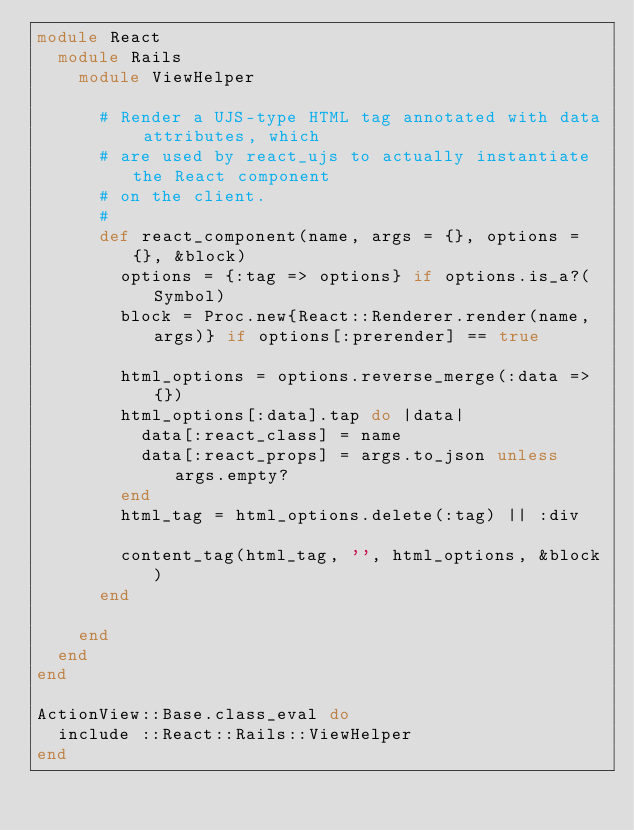<code> <loc_0><loc_0><loc_500><loc_500><_Ruby_>module React
  module Rails
    module ViewHelper

      # Render a UJS-type HTML tag annotated with data attributes, which
      # are used by react_ujs to actually instantiate the React component
      # on the client.
      #
      def react_component(name, args = {}, options = {}, &block)
        options = {:tag => options} if options.is_a?(Symbol)
        block = Proc.new{React::Renderer.render(name, args)} if options[:prerender] == true

        html_options = options.reverse_merge(:data => {})
        html_options[:data].tap do |data|
          data[:react_class] = name
          data[:react_props] = args.to_json unless args.empty?
        end
        html_tag = html_options.delete(:tag) || :div

        content_tag(html_tag, '', html_options, &block)
      end

    end
  end
end

ActionView::Base.class_eval do
  include ::React::Rails::ViewHelper
end
</code> 